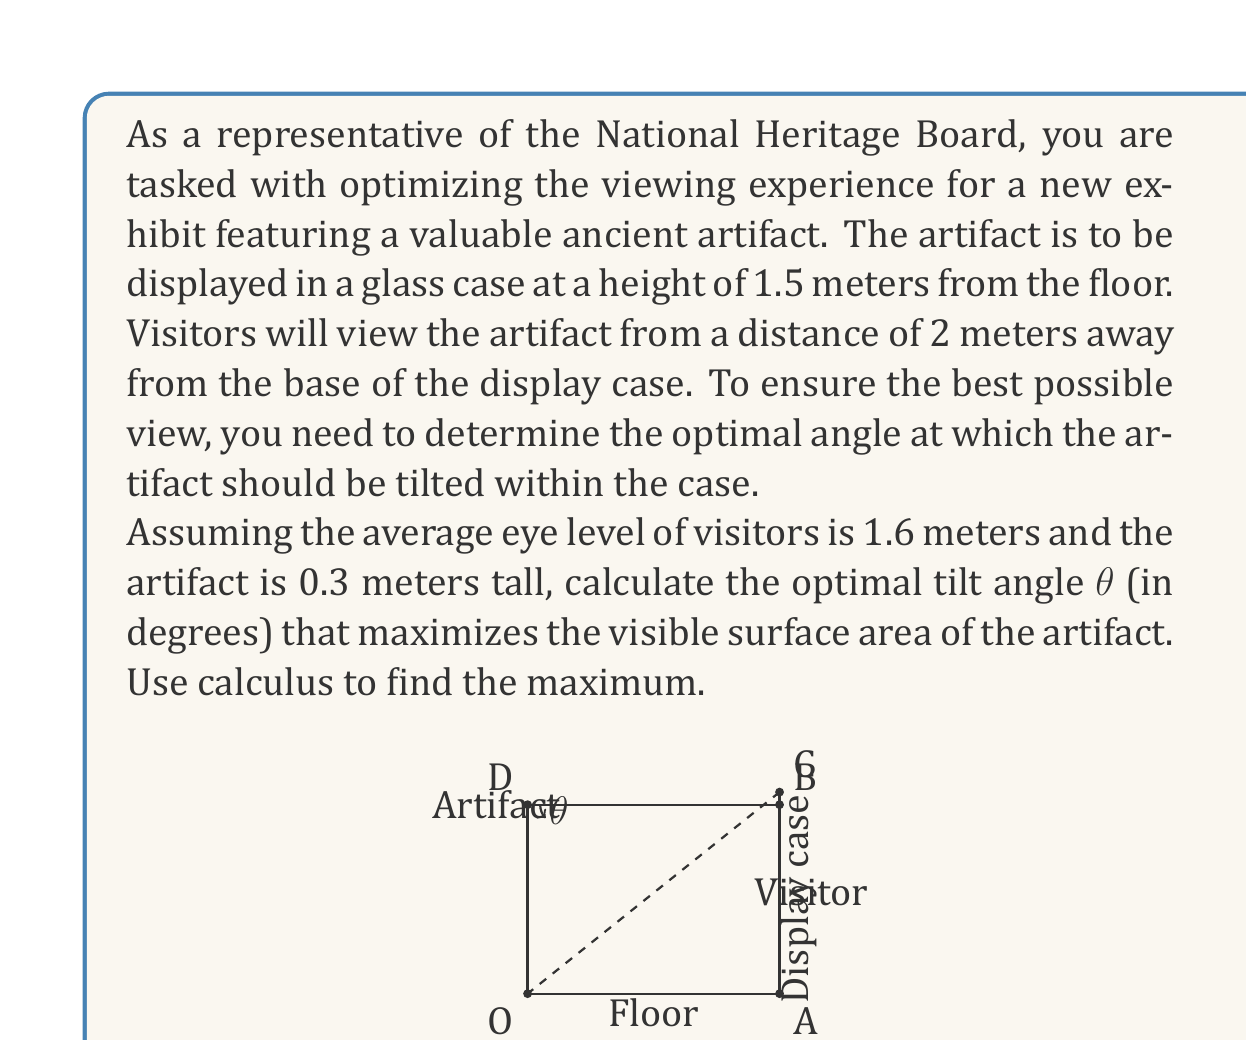Provide a solution to this math problem. Let's approach this problem step by step:

1) First, we need to set up a function that represents the visible surface area of the artifact based on the tilt angle $\theta$.

2) The visible surface area will be proportional to the sine of the angle between the line of sight and the surface normal of the artifact.

3) Let's define our coordinate system with the origin at the base of the display case. The artifact's center will be at (0, 1.5) and the visitor's eyes at (2, 1.6).

4) The line of sight vector $\vec{v}$ is:
   $$\vec{v} = (2, 0.1)$$

5) The surface normal vector $\vec{n}$ of the artifact, when tilted by angle $\theta$, is:
   $$\vec{n} = (-\sin\theta, \cos\theta)$$

6) The angle $\alpha$ between these vectors is given by their dot product:
   $$\cos\alpha = \frac{\vec{v} \cdot \vec{n}}{|\vec{v}||\vec{n}|} = \frac{-2\sin\theta + 0.1\cos\theta}{\sqrt{4.01}}$$

7) The visible surface area is proportional to $\sin\alpha$, which we can express as:
   $$\sin\alpha = \sqrt{1 - \cos^2\alpha} = \sqrt{1 - \frac{(-2\sin\theta + 0.1\cos\theta)^2}{4.01}}$$

8) Let's call this function $f(\theta)$. To find the maximum, we need to find where $f'(\theta) = 0$.

9) Taking the derivative and setting it to zero:
   $$f'(\theta) = \frac{(-2\sin\theta + 0.1\cos\theta)(2\cos\theta + 0.1\sin\theta)}{4.01\sqrt{1 - \frac{(-2\sin\theta + 0.1\cos\theta)^2}{4.01}}} = 0$$

10) This equation is satisfied when the numerator is zero:
    $$(-2\sin\theta + 0.1\cos\theta)(2\cos\theta + 0.1\sin\theta) = 0$$

11) Solving this equation:
    $$-2\sin\theta + 0.1\cos\theta = 0$$
    $$\tan\theta = 0.05$$
    $$\theta = \arctan(0.05)$$

12) Converting to degrees:
    $$\theta \approx 2.86°$$

13) We should verify that this is indeed a maximum by checking the second derivative or by examining the function near this point.
Answer: The optimal tilt angle for the artifact is approximately $2.86°$ upward from the horizontal. 